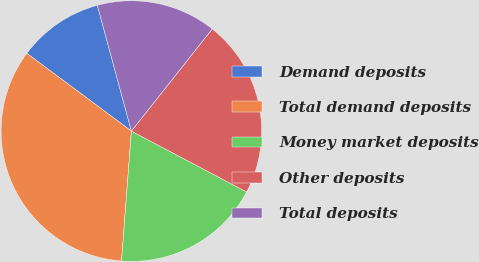Convert chart. <chart><loc_0><loc_0><loc_500><loc_500><pie_chart><fcel>Demand deposits<fcel>Total demand deposits<fcel>Money market deposits<fcel>Other deposits<fcel>Total deposits<nl><fcel>10.62%<fcel>33.97%<fcel>18.47%<fcel>22.08%<fcel>14.86%<nl></chart> 